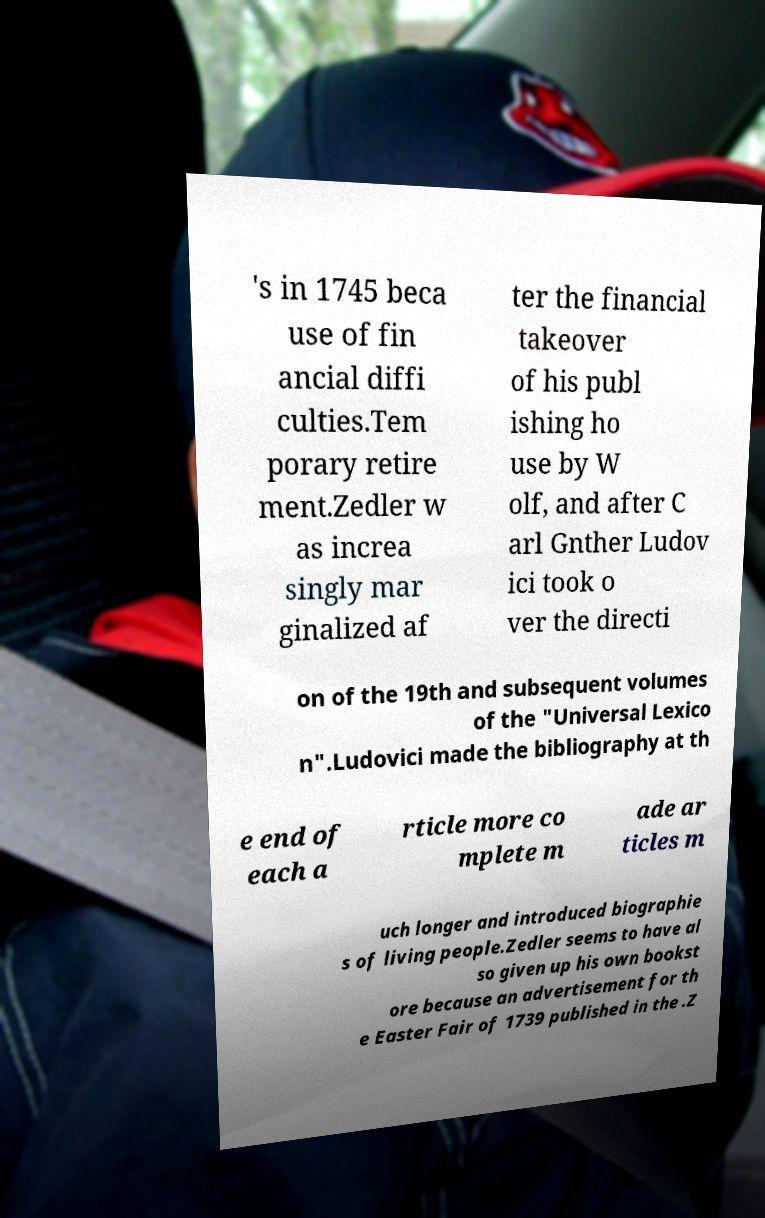I need the written content from this picture converted into text. Can you do that? 's in 1745 beca use of fin ancial diffi culties.Tem porary retire ment.Zedler w as increa singly mar ginalized af ter the financial takeover of his publ ishing ho use by W olf, and after C arl Gnther Ludov ici took o ver the directi on of the 19th and subsequent volumes of the "Universal Lexico n".Ludovici made the bibliography at th e end of each a rticle more co mplete m ade ar ticles m uch longer and introduced biographie s of living people.Zedler seems to have al so given up his own bookst ore because an advertisement for th e Easter Fair of 1739 published in the .Z 